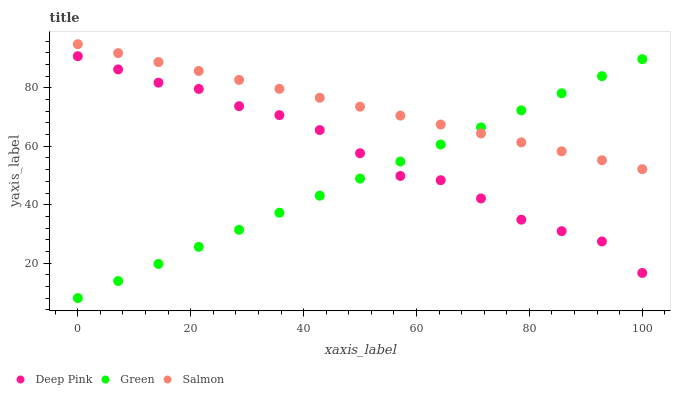Does Green have the minimum area under the curve?
Answer yes or no. Yes. Does Salmon have the maximum area under the curve?
Answer yes or no. Yes. Does Deep Pink have the minimum area under the curve?
Answer yes or no. No. Does Deep Pink have the maximum area under the curve?
Answer yes or no. No. Is Green the smoothest?
Answer yes or no. Yes. Is Deep Pink the roughest?
Answer yes or no. Yes. Is Deep Pink the smoothest?
Answer yes or no. No. Is Green the roughest?
Answer yes or no. No. Does Green have the lowest value?
Answer yes or no. Yes. Does Deep Pink have the lowest value?
Answer yes or no. No. Does Salmon have the highest value?
Answer yes or no. Yes. Does Deep Pink have the highest value?
Answer yes or no. No. Is Deep Pink less than Salmon?
Answer yes or no. Yes. Is Salmon greater than Deep Pink?
Answer yes or no. Yes. Does Green intersect Salmon?
Answer yes or no. Yes. Is Green less than Salmon?
Answer yes or no. No. Is Green greater than Salmon?
Answer yes or no. No. Does Deep Pink intersect Salmon?
Answer yes or no. No. 